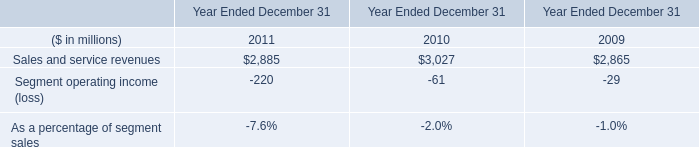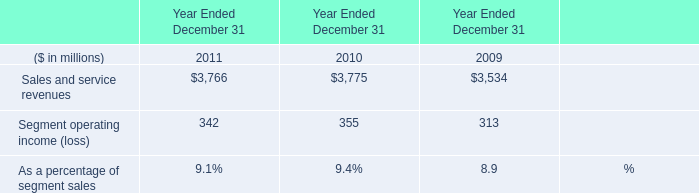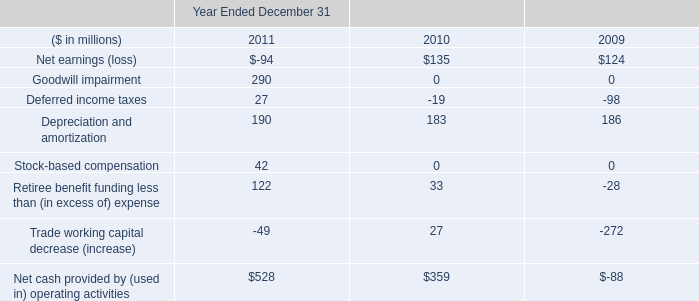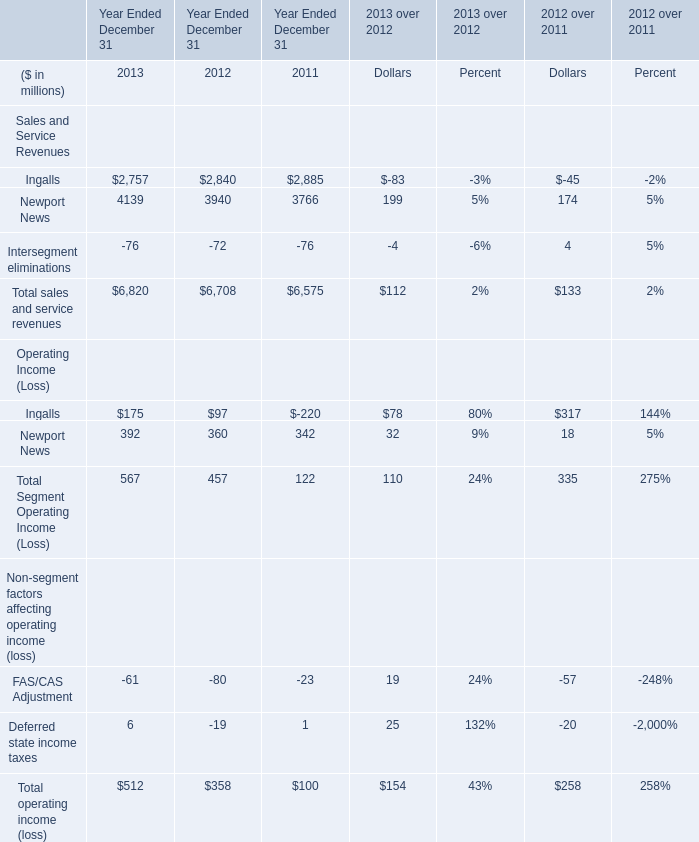Which Sales and Service Revenues exceeds 10% of total in 2012? 
Answer: Ingalls, Newport News. 